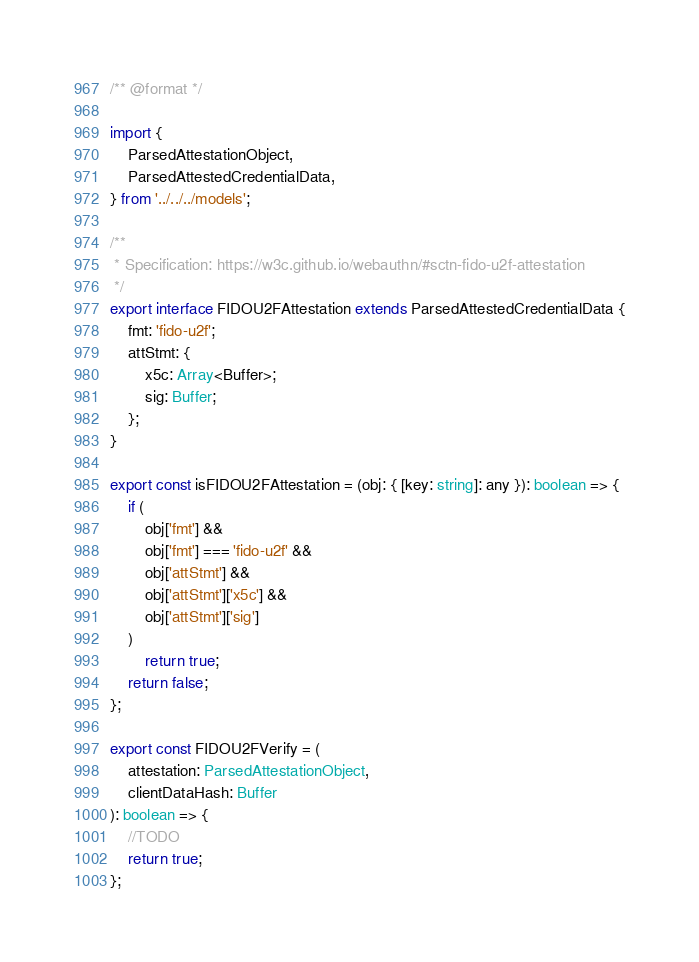<code> <loc_0><loc_0><loc_500><loc_500><_TypeScript_>/** @format */

import {
	ParsedAttestationObject,
	ParsedAttestedCredentialData,
} from '../../../models';

/**
 * Specification: https://w3c.github.io/webauthn/#sctn-fido-u2f-attestation
 */
export interface FIDOU2FAttestation extends ParsedAttestedCredentialData {
	fmt: 'fido-u2f';
	attStmt: {
		x5c: Array<Buffer>;
		sig: Buffer;
	};
}

export const isFIDOU2FAttestation = (obj: { [key: string]: any }): boolean => {
	if (
		obj['fmt'] &&
		obj['fmt'] === 'fido-u2f' &&
		obj['attStmt'] &&
		obj['attStmt']['x5c'] &&
		obj['attStmt']['sig']
	)
		return true;
	return false;
};

export const FIDOU2FVerify = (
	attestation: ParsedAttestationObject,
	clientDataHash: Buffer
): boolean => {
	//TODO
	return true;
};
</code> 